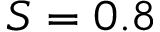Convert formula to latex. <formula><loc_0><loc_0><loc_500><loc_500>S = 0 . 8</formula> 